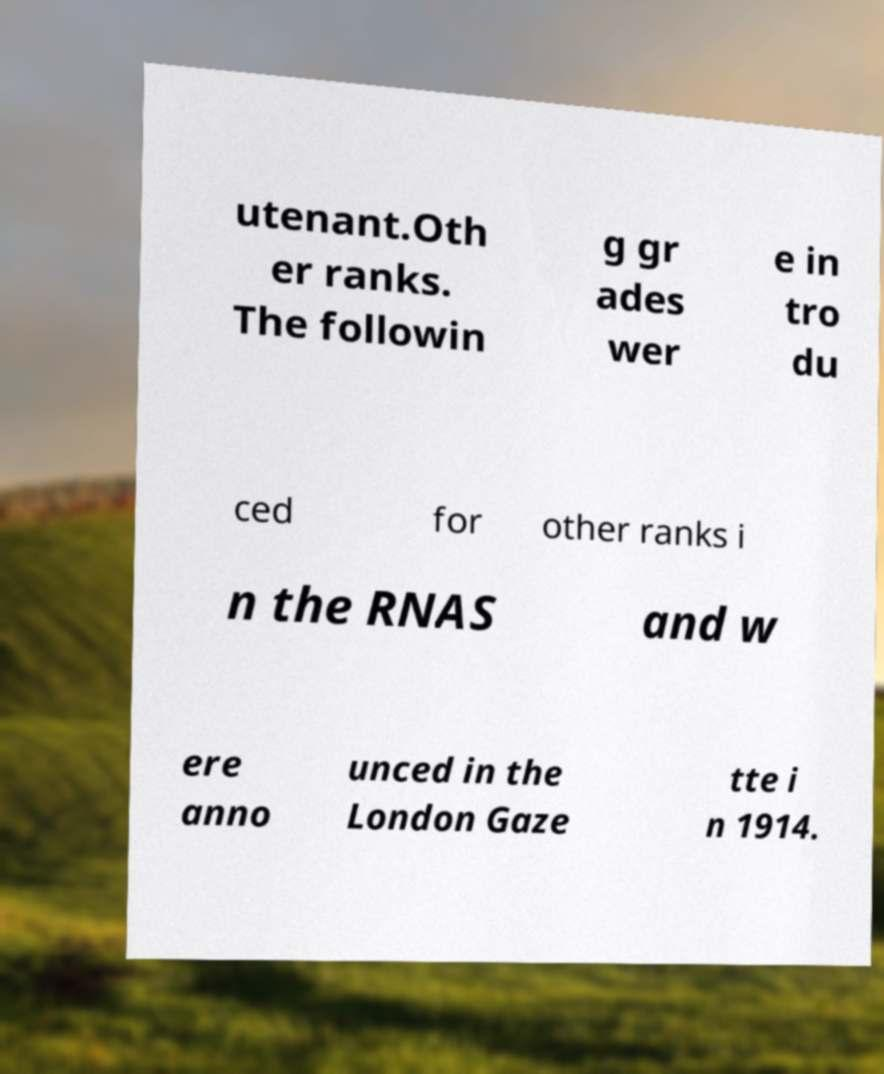Could you extract and type out the text from this image? utenant.Oth er ranks. The followin g gr ades wer e in tro du ced for other ranks i n the RNAS and w ere anno unced in the London Gaze tte i n 1914. 